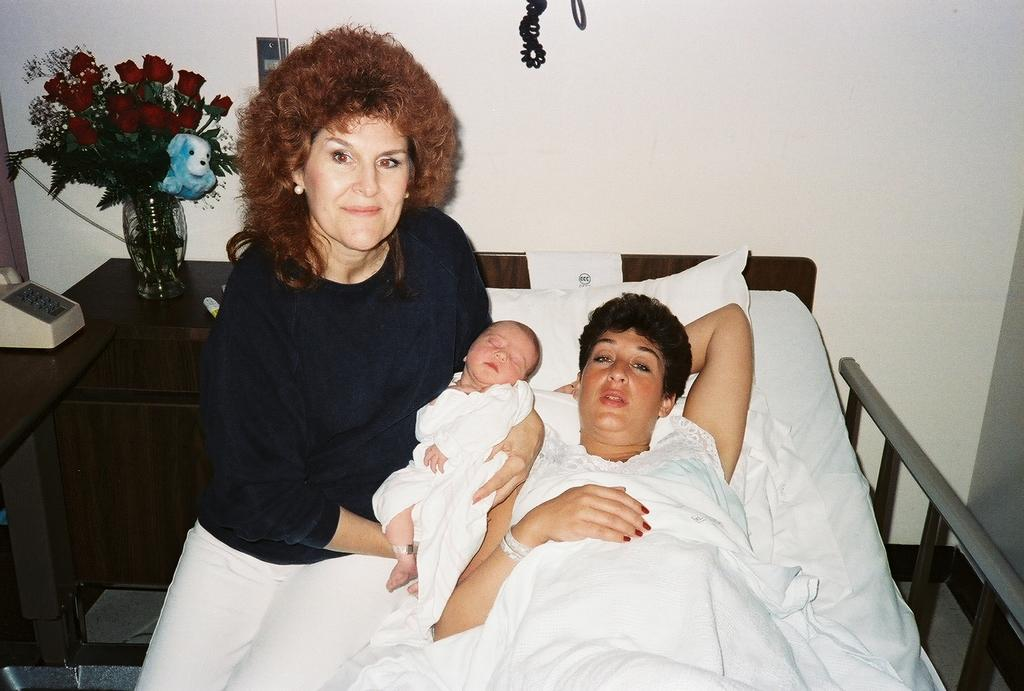What is the woman doing in the image? The woman is sitting and holding a baby in the image. Where is the woman located in the image? The woman is laying on a bed in the image. What objects can be seen on the table in the image? There is a telephone and a flower vase on the table in the image. What type of scent can be detected from the alley in the image? There is no alley present in the image, so it is not possible to detect any scent from it. 